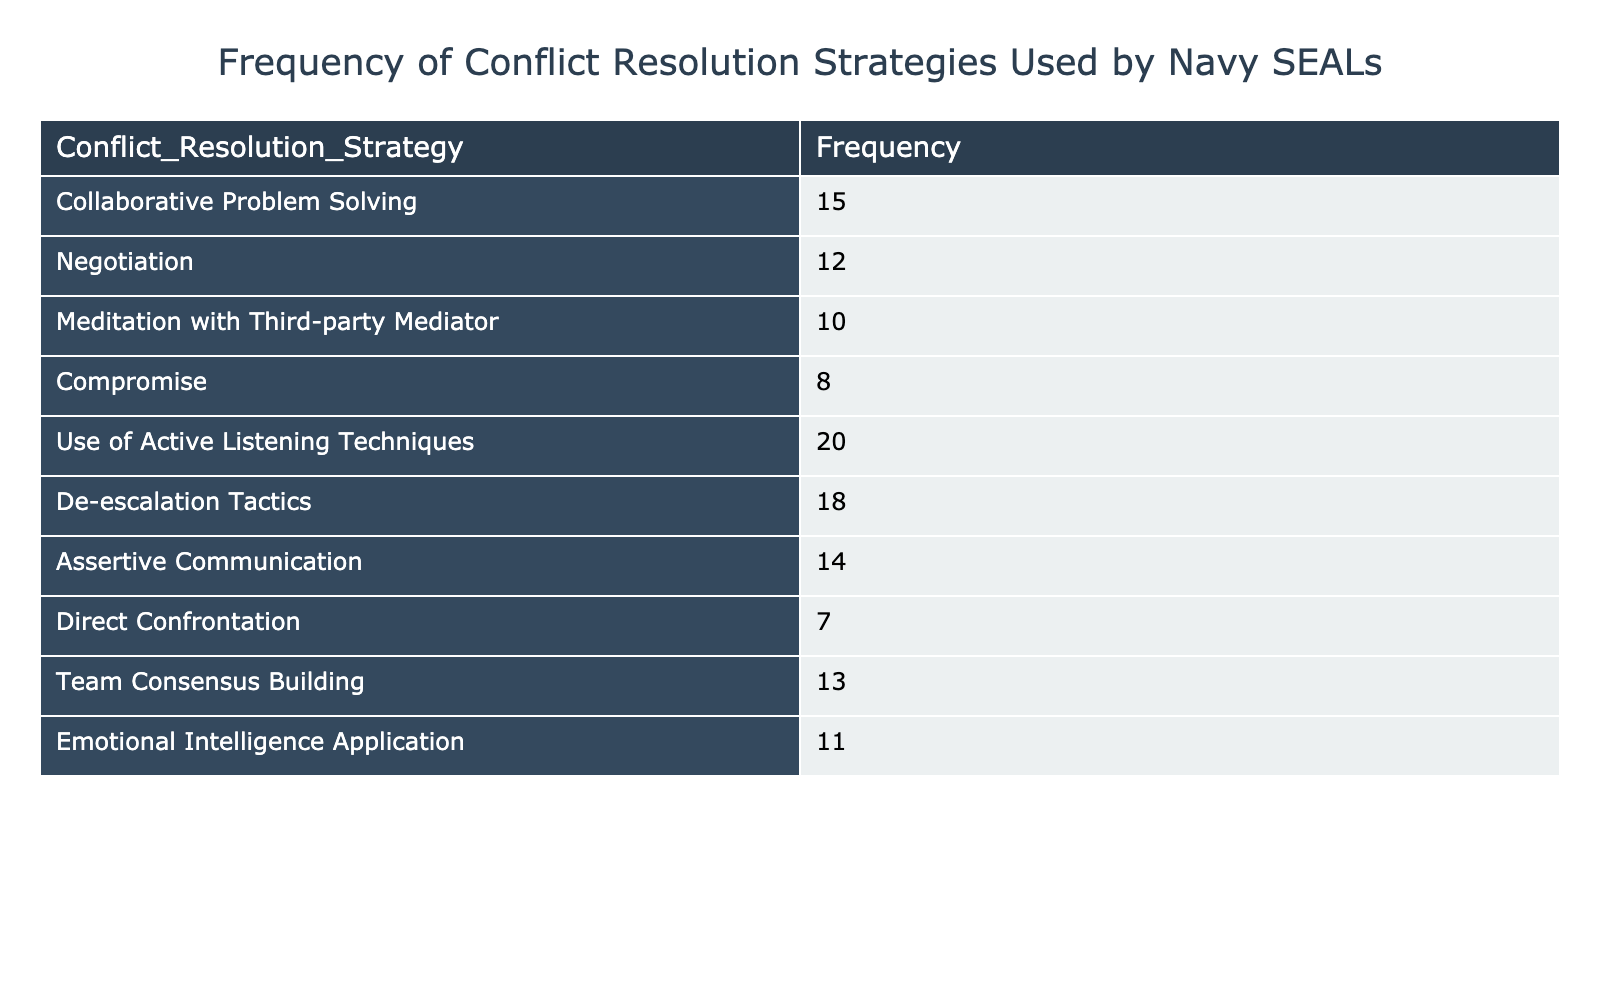What is the frequency of use of Active Listening Techniques? The table lists the frequencies of various conflict resolution strategies. By locating the row for "Use of Active Listening Techniques," we can see that it has a frequency of 20.
Answer: 20 Which conflict resolution strategy has the highest frequency? By examining the frequencies in the table, we can identify that "Use of Active Listening Techniques" has the highest frequency of 20.
Answer: Use of Active Listening Techniques What is the sum of the frequencies of Negotiation and Compromise? The frequency for "Negotiation" is 12 and for "Compromise" it is 8. Adding these two values together (12 + 8) gives us 20.
Answer: 20 Is the frequency of De-escalation Tactics greater than the frequency of Meditation with Third-party Mediator? The frequency for De-escalation Tactics is 18 and for Meditation with Third-party Mediator it is 10. Since 18 is greater than 10, the statement is true.
Answer: Yes What is the average frequency of the conflict resolution strategies listed? To find the average frequency, we first sum all the frequencies: 15 + 12 + 10 + 8 + 20 + 18 + 14 + 7 + 13 + 11 =  138. Dividing this sum by the number of strategies (10), we get an average of 138 / 10 = 13.8.
Answer: 13.8 How many conflict resolution strategies have a frequency greater than 15? By reviewing the frequencies, we find: Active Listening Techniques (20), De-escalation Tactics (18), and Collaborative Problem Solving (15) have frequencies greater than 15. That totals to three strategies.
Answer: 3 What is the difference in frequency between Assertive Communication and Direct Confrontation? The frequency for Assertive Communication is 14 and for Direct Confrontation it is 7. The difference, calculated as 14 - 7, results in a value of 7.
Answer: 7 Which two strategies combined have a frequency that is less than the frequency of Team Consensus Building? Team Consensus Building has a frequency of 13. Examining the combinations, the pair of Direct Confrontation (7) and Compromise (8) has a sum of 15, which exceeds 13. While the pair of Assertive Communication (14) and Meditation with Third-party Mediator (10) also sums to 24. The combination of Emotional Intelligence Application (11) and Direct Confrontation (7) equals 18, still greater than 13. However, the pair of Compromise (8) and Direct Confrontation (7) sums to 15. Hence, there are no possible pairs.
Answer: None Is the frequency of Emotional Intelligence Application equal to Assertive Communication? The frequency for Emotional Intelligence Application is 11 and for Assertive Communication is 14. Since 11 is not equal to 14, the statement is false.
Answer: No 